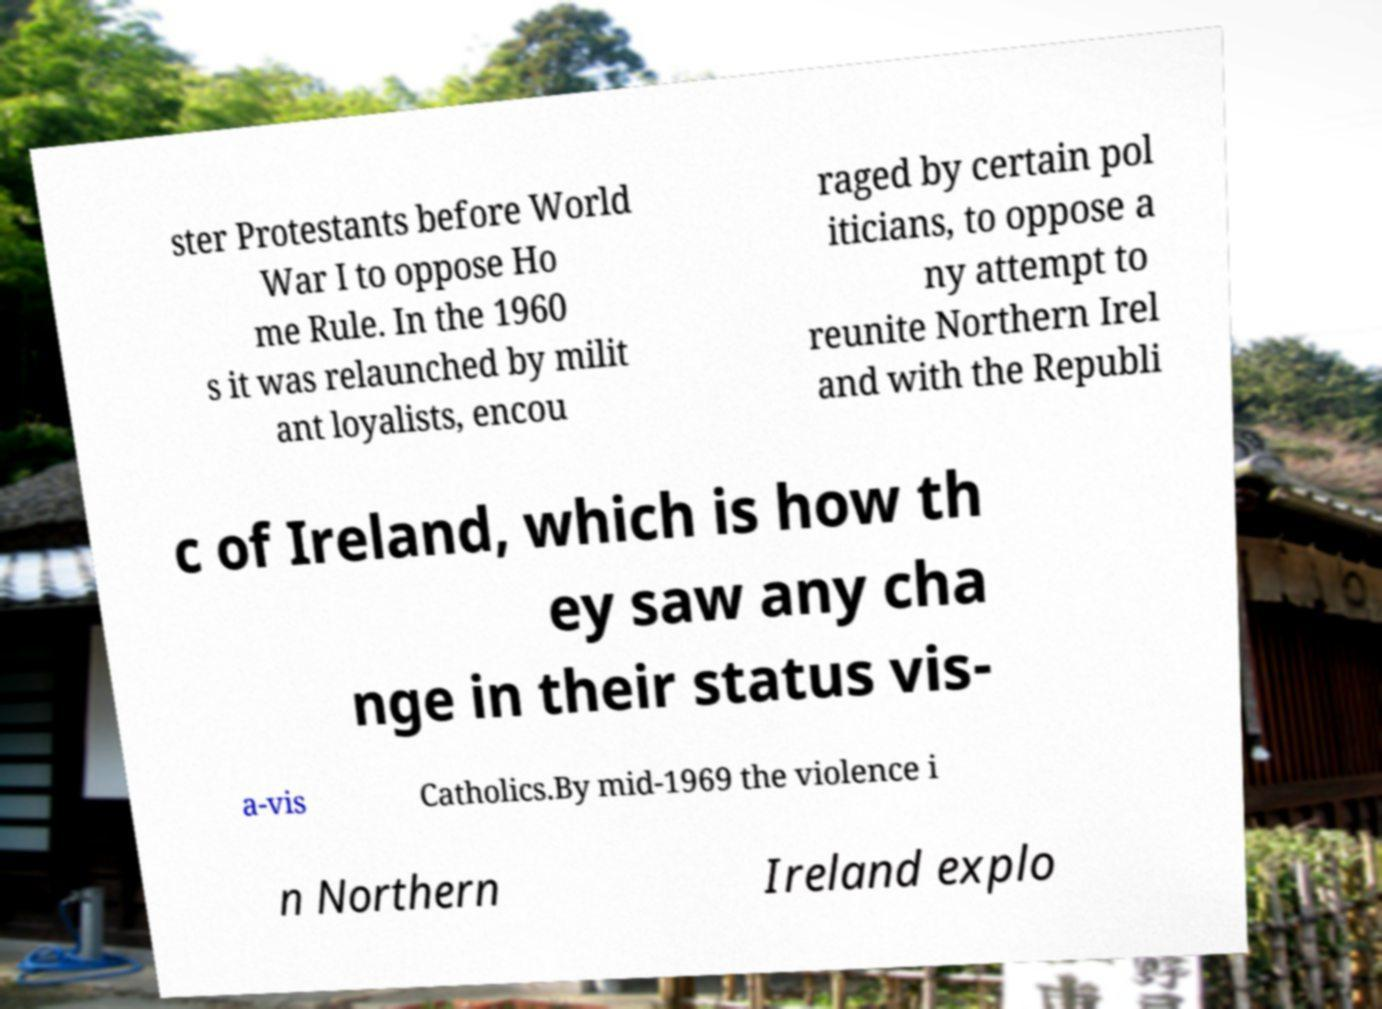Can you read and provide the text displayed in the image?This photo seems to have some interesting text. Can you extract and type it out for me? ster Protestants before World War I to oppose Ho me Rule. In the 1960 s it was relaunched by milit ant loyalists, encou raged by certain pol iticians, to oppose a ny attempt to reunite Northern Irel and with the Republi c of Ireland, which is how th ey saw any cha nge in their status vis- a-vis Catholics.By mid-1969 the violence i n Northern Ireland explo 